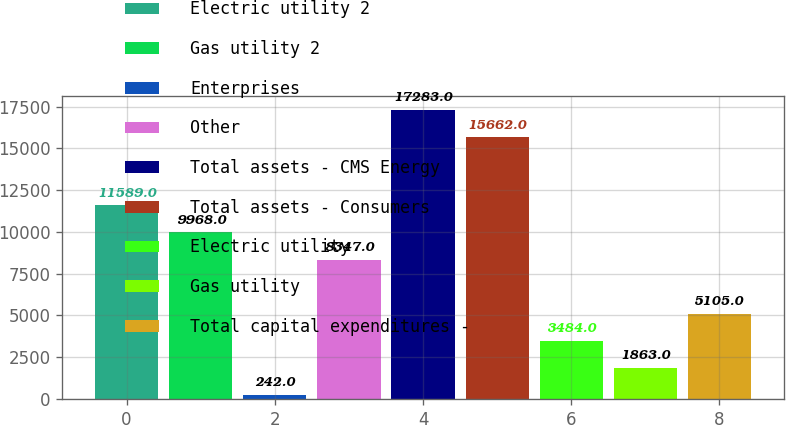<chart> <loc_0><loc_0><loc_500><loc_500><bar_chart><fcel>Electric utility 2<fcel>Gas utility 2<fcel>Enterprises<fcel>Other<fcel>Total assets - CMS Energy<fcel>Total assets - Consumers<fcel>Electric utility<fcel>Gas utility<fcel>Total capital expenditures -<nl><fcel>11589<fcel>9968<fcel>242<fcel>8347<fcel>17283<fcel>15662<fcel>3484<fcel>1863<fcel>5105<nl></chart> 